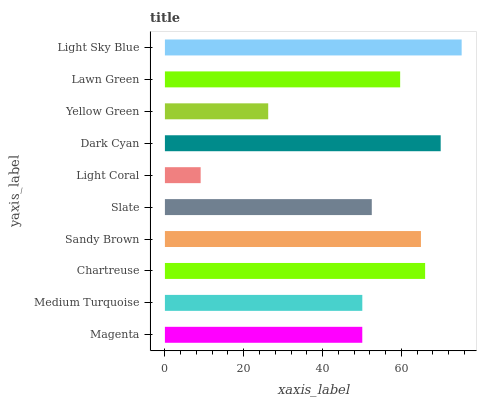Is Light Coral the minimum?
Answer yes or no. Yes. Is Light Sky Blue the maximum?
Answer yes or no. Yes. Is Medium Turquoise the minimum?
Answer yes or no. No. Is Medium Turquoise the maximum?
Answer yes or no. No. Is Medium Turquoise greater than Magenta?
Answer yes or no. Yes. Is Magenta less than Medium Turquoise?
Answer yes or no. Yes. Is Magenta greater than Medium Turquoise?
Answer yes or no. No. Is Medium Turquoise less than Magenta?
Answer yes or no. No. Is Lawn Green the high median?
Answer yes or no. Yes. Is Slate the low median?
Answer yes or no. Yes. Is Magenta the high median?
Answer yes or no. No. Is Lawn Green the low median?
Answer yes or no. No. 